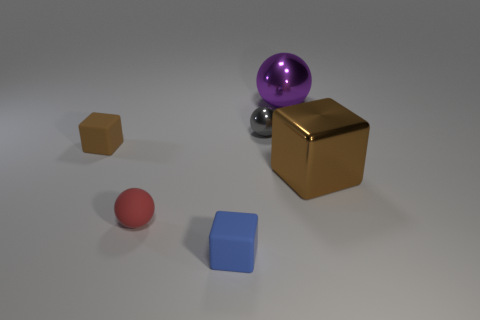What is the size of the gray object that is the same shape as the big purple metallic object?
Keep it short and to the point. Small. There is a metallic object that is on the right side of the gray shiny sphere and behind the brown rubber thing; what shape is it?
Ensure brevity in your answer.  Sphere. There is a blue matte block; is it the same size as the metallic thing on the left side of the purple thing?
Ensure brevity in your answer.  Yes. What color is the other small object that is the same shape as the blue rubber object?
Ensure brevity in your answer.  Brown. Do the block that is right of the big shiny sphere and the matte cube on the left side of the blue matte cube have the same size?
Your answer should be compact. No. Do the brown metal thing and the small metallic object have the same shape?
Provide a short and direct response. No. What number of things are spheres that are in front of the large shiny ball or small purple metal balls?
Your answer should be compact. 2. Are there any large green rubber things that have the same shape as the brown matte thing?
Provide a short and direct response. No. Are there the same number of purple balls behind the purple thing and blue rubber cubes?
Ensure brevity in your answer.  No. The rubber object that is the same color as the large metallic cube is what shape?
Provide a short and direct response. Cube. 